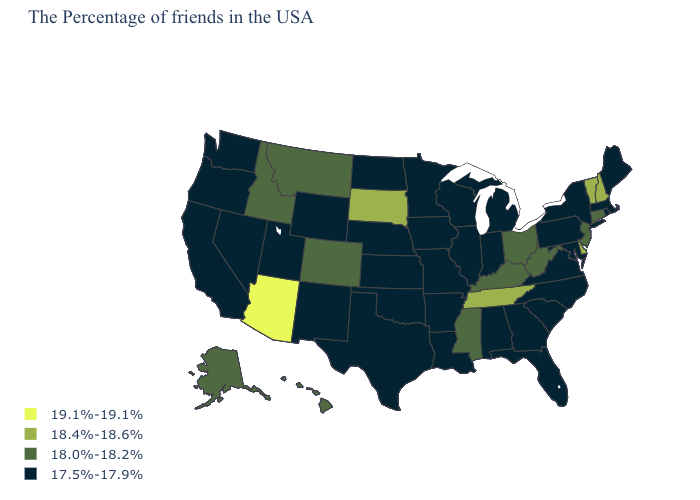What is the value of Utah?
Quick response, please. 17.5%-17.9%. What is the lowest value in states that border Utah?
Be succinct. 17.5%-17.9%. Name the states that have a value in the range 18.0%-18.2%?
Answer briefly. Connecticut, New Jersey, West Virginia, Ohio, Kentucky, Mississippi, Colorado, Montana, Idaho, Alaska, Hawaii. Name the states that have a value in the range 17.5%-17.9%?
Keep it brief. Maine, Massachusetts, Rhode Island, New York, Maryland, Pennsylvania, Virginia, North Carolina, South Carolina, Florida, Georgia, Michigan, Indiana, Alabama, Wisconsin, Illinois, Louisiana, Missouri, Arkansas, Minnesota, Iowa, Kansas, Nebraska, Oklahoma, Texas, North Dakota, Wyoming, New Mexico, Utah, Nevada, California, Washington, Oregon. Name the states that have a value in the range 18.0%-18.2%?
Answer briefly. Connecticut, New Jersey, West Virginia, Ohio, Kentucky, Mississippi, Colorado, Montana, Idaho, Alaska, Hawaii. Name the states that have a value in the range 18.4%-18.6%?
Be succinct. New Hampshire, Vermont, Delaware, Tennessee, South Dakota. Name the states that have a value in the range 17.5%-17.9%?
Keep it brief. Maine, Massachusetts, Rhode Island, New York, Maryland, Pennsylvania, Virginia, North Carolina, South Carolina, Florida, Georgia, Michigan, Indiana, Alabama, Wisconsin, Illinois, Louisiana, Missouri, Arkansas, Minnesota, Iowa, Kansas, Nebraska, Oklahoma, Texas, North Dakota, Wyoming, New Mexico, Utah, Nevada, California, Washington, Oregon. Among the states that border Connecticut , which have the highest value?
Be succinct. Massachusetts, Rhode Island, New York. Which states hav the highest value in the MidWest?
Quick response, please. South Dakota. What is the value of Florida?
Write a very short answer. 17.5%-17.9%. Name the states that have a value in the range 19.1%-19.1%?
Quick response, please. Arizona. What is the value of Massachusetts?
Concise answer only. 17.5%-17.9%. Among the states that border New Jersey , which have the lowest value?
Concise answer only. New York, Pennsylvania. Does Oklahoma have a higher value than Wyoming?
Concise answer only. No. What is the value of Kansas?
Quick response, please. 17.5%-17.9%. 